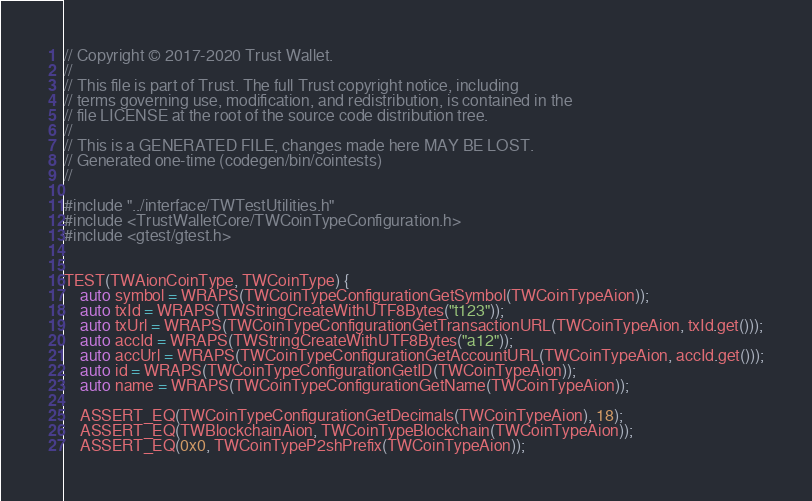<code> <loc_0><loc_0><loc_500><loc_500><_C++_>// Copyright © 2017-2020 Trust Wallet.
//
// This file is part of Trust. The full Trust copyright notice, including
// terms governing use, modification, and redistribution, is contained in the
// file LICENSE at the root of the source code distribution tree.
//
// This is a GENERATED FILE, changes made here MAY BE LOST.
// Generated one-time (codegen/bin/cointests)
//

#include "../interface/TWTestUtilities.h"
#include <TrustWalletCore/TWCoinTypeConfiguration.h>
#include <gtest/gtest.h>


TEST(TWAionCoinType, TWCoinType) {
    auto symbol = WRAPS(TWCoinTypeConfigurationGetSymbol(TWCoinTypeAion));
    auto txId = WRAPS(TWStringCreateWithUTF8Bytes("t123"));
    auto txUrl = WRAPS(TWCoinTypeConfigurationGetTransactionURL(TWCoinTypeAion, txId.get()));
    auto accId = WRAPS(TWStringCreateWithUTF8Bytes("a12"));
    auto accUrl = WRAPS(TWCoinTypeConfigurationGetAccountURL(TWCoinTypeAion, accId.get()));
    auto id = WRAPS(TWCoinTypeConfigurationGetID(TWCoinTypeAion));
    auto name = WRAPS(TWCoinTypeConfigurationGetName(TWCoinTypeAion));

    ASSERT_EQ(TWCoinTypeConfigurationGetDecimals(TWCoinTypeAion), 18);
    ASSERT_EQ(TWBlockchainAion, TWCoinTypeBlockchain(TWCoinTypeAion));
    ASSERT_EQ(0x0, TWCoinTypeP2shPrefix(TWCoinTypeAion));</code> 